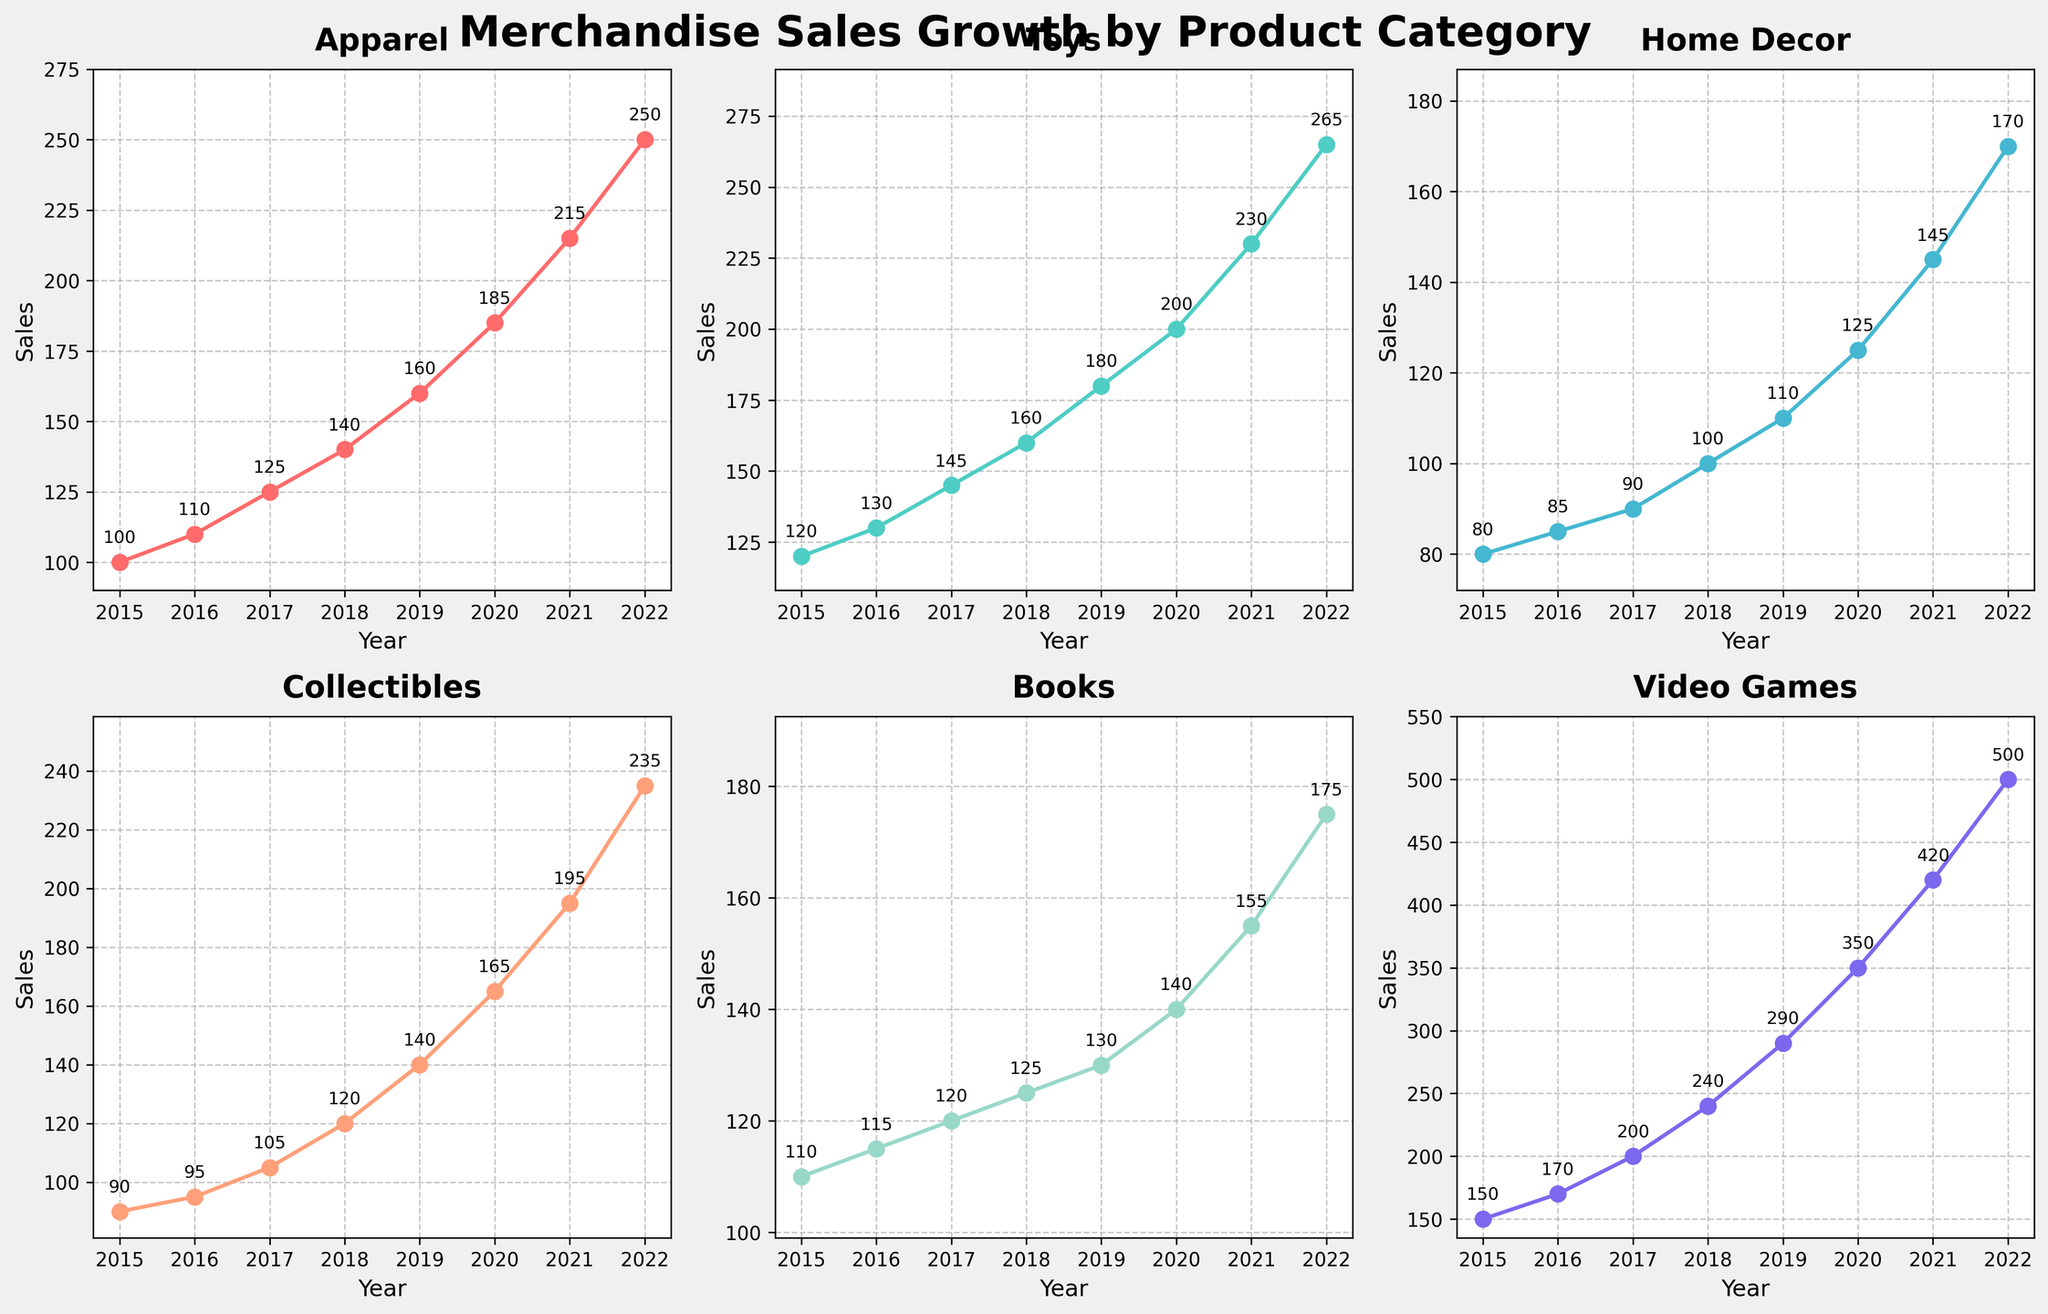How has the apparel sales grown from 2015 to 2022? To find this, locate the "Apparel" line on the plot and note the values for the years 2015 and 2022. In 2015, the sales were 100 units, and in 2022, the sales were 250 units. The growth is 250 - 100.
Answer: 150 Which product category had the highest sales in 2022? In 2022, look at the final data points of each line in the figure. The highest value corresponds to "Video Games" with 500 units.
Answer: Video Games When comparing "Books" and "Home Decor," which had higher sales in 2017, and by how much? Find the values of "Books" and "Home Decor" for the year 2017. "Books" had sales of 120 units, and "Home Decor" had sales of 90 units. The difference is 120 - 90.
Answer: Books, by 30 units What is the average annual sales growth rate of "Toys" from 2015 to 2022? Find the "Toys" sales values for 2015 and 2022, which are 120 and 265, respectively. Calculate the total growth (265 - 120 = 145 units). Divide this by the number of years (2022 - 2015 = 7 years), resulting in average annual growth.
Answer: 20.71 units per year Which category had the least growth in sales from 2015 to 2022? Subtract the 2015 value from the 2022 value for each category. "Home Decor" grew from 80 to 170 units, which is a growth of 90 units, the smallest growth among the categories.
Answer: Home Decor Was there any category that experienced a year-over-year decrease? Evaluate each line for peaks followed by drops. No category shows a year-over-year decrease; all lines consistently rise year after year.
Answer: No Between 2019 and 2020, which category showed the highest percentage increase in sales? Calculate the percentage increase for each category: ((2020 value - 2019 value) / 2019 value) * 100. "Video Games" increased from 290 to 350 units, resulting in ((350 - 290) / 290) * 100 = ~20.69%.
Answer: Video Games How did collectibles sales change between 2016 and 2018? Look at the points of "Collectibles" for 2016 and 2018, which are 95 and 120 units, respectively. The difference is 120 - 95.
Answer: Increased by 25 units 